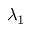Convert formula to latex. <formula><loc_0><loc_0><loc_500><loc_500>\lambda _ { 1 }</formula> 